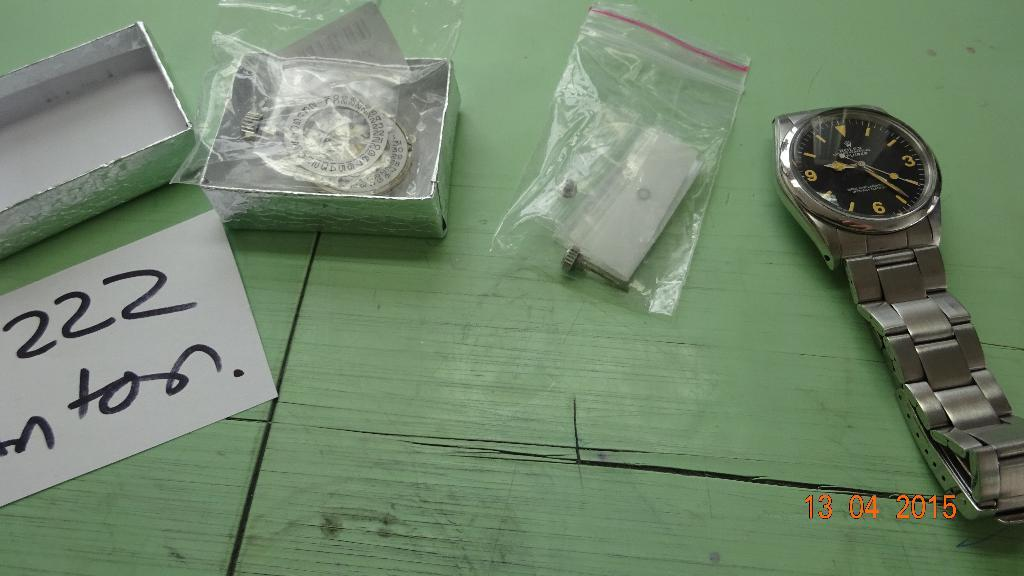<image>
Write a terse but informative summary of the picture. A watch is next to a bag containing paper and a box with a trinket in it labeled 222 nton. 